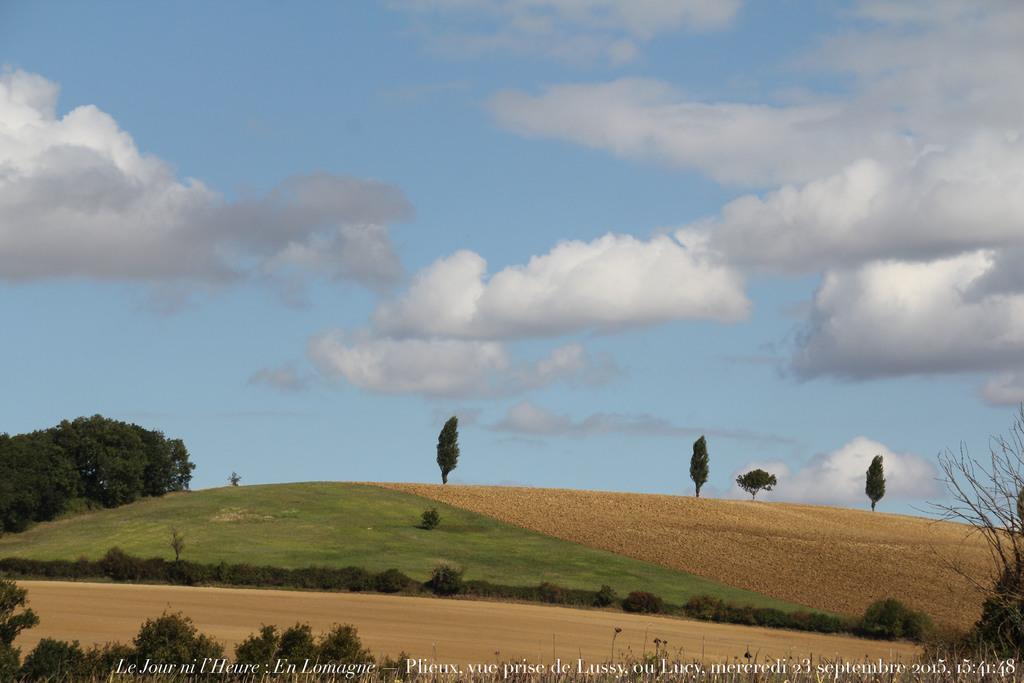Describe this image in one or two sentences. In this image there are trees and mud at the bottom. There are trees on the left and right corner. There is green grass, small plants and trees in the background. And there is sky at the top. 